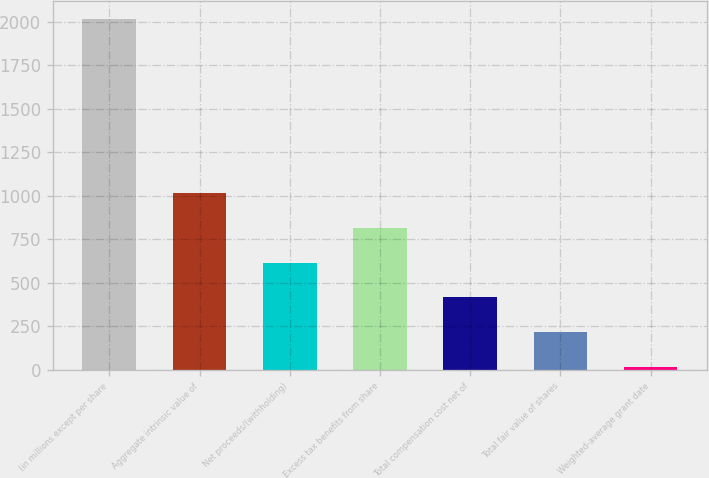Convert chart to OTSL. <chart><loc_0><loc_0><loc_500><loc_500><bar_chart><fcel>(in millions except per share<fcel>Aggregate intrinsic value of<fcel>Net proceeds/(withholding)<fcel>Excess tax benefits from share<fcel>Total compensation cost net of<fcel>Total fair value of shares<fcel>Weighted-average grant date<nl><fcel>2017<fcel>1016.82<fcel>616.76<fcel>816.79<fcel>416.73<fcel>216.7<fcel>16.67<nl></chart> 